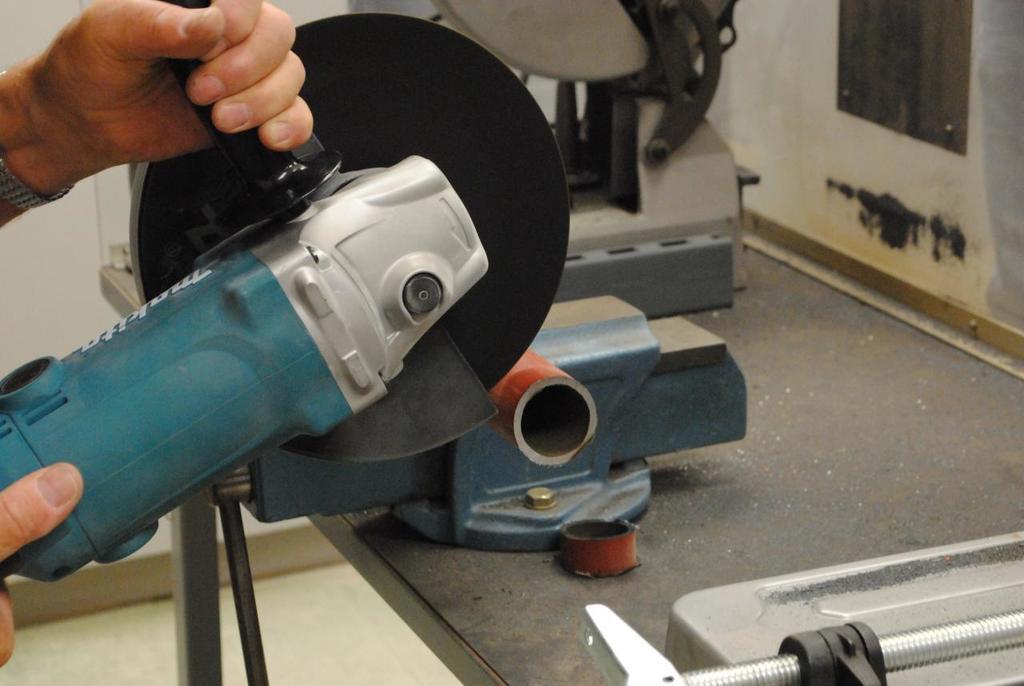Describe this image in one or two sentences. Here we can see a person holding an angle grinder. This is floor and there are objects. In the background we can see wall. 